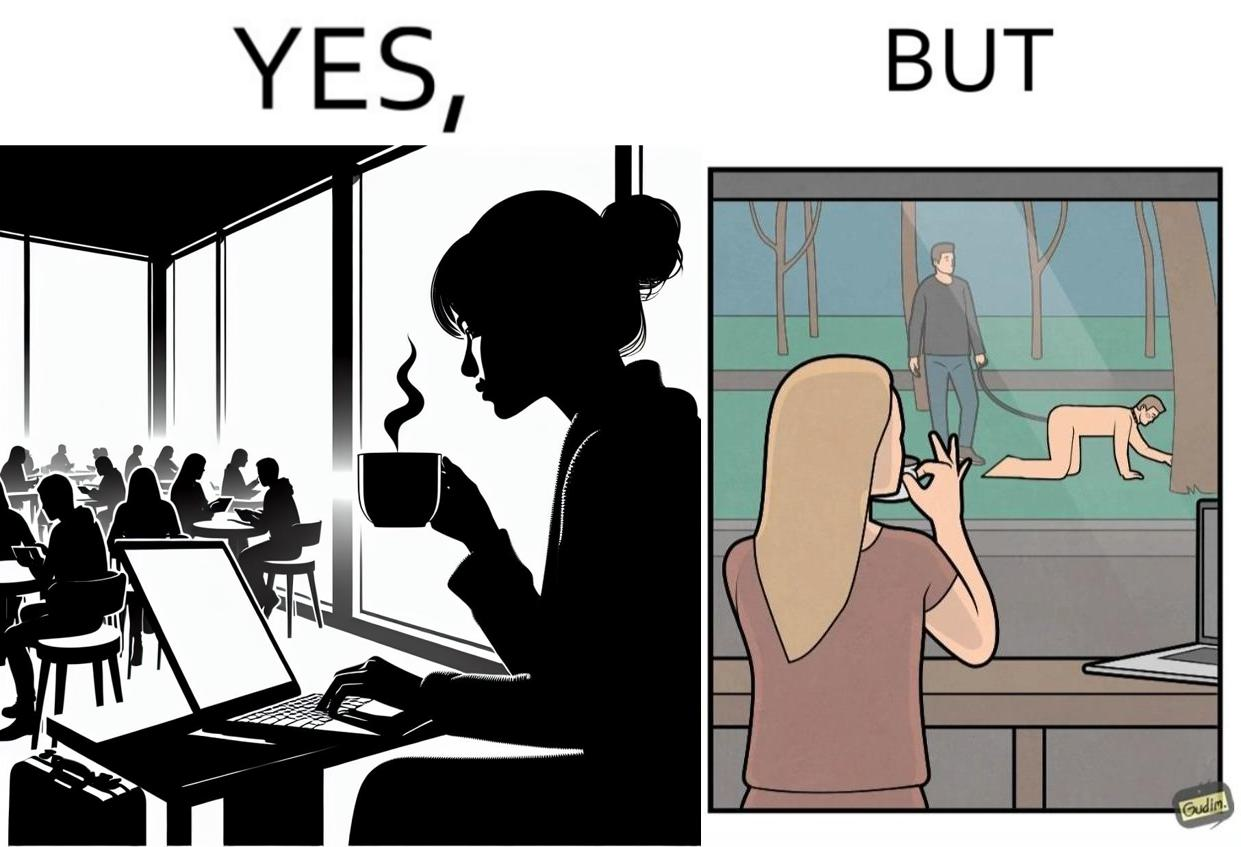Does this image contain satire or humor? Yes, this image is satirical. 